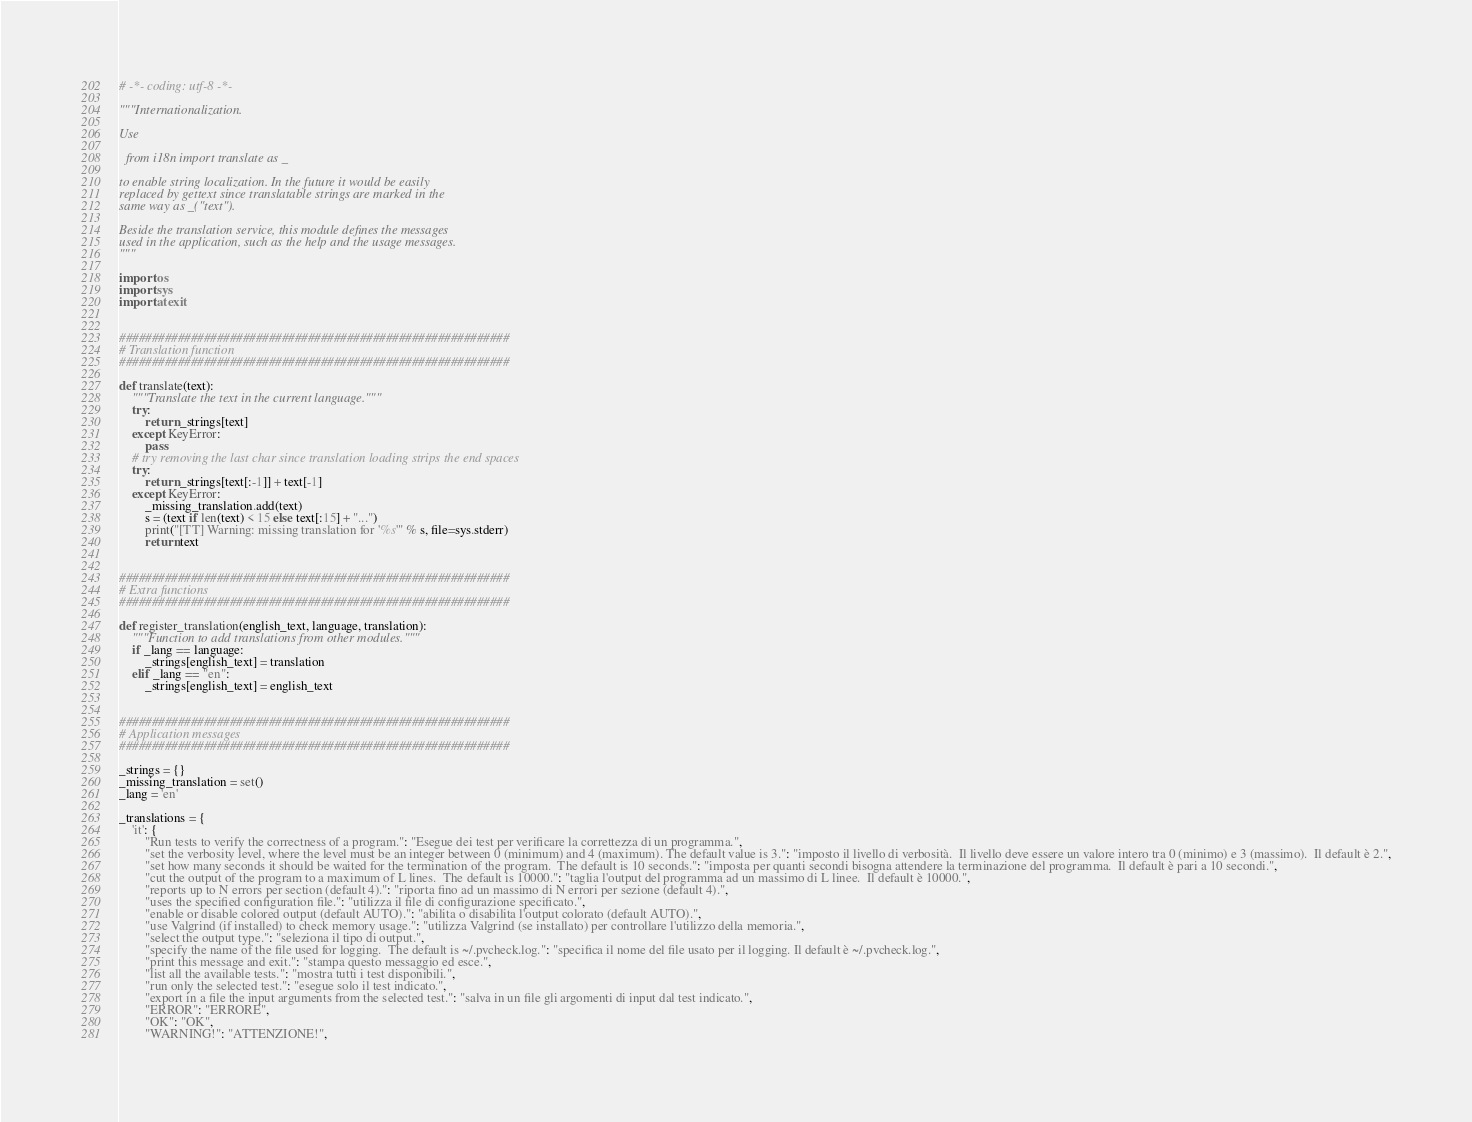<code> <loc_0><loc_0><loc_500><loc_500><_Python_># -*- coding: utf-8 -*-

"""Internationalization.

Use

  from i18n import translate as _

to enable string localization. In the future it would be easily
replaced by gettext since translatable strings are marked in the
same way as _("text").

Beside the translation service, this module defines the messages
used in the application, such as the help and the usage messages.
"""

import os
import sys
import atexit


############################################################
# Translation function
############################################################

def translate(text):
    """Translate the text in the current language."""
    try:
        return _strings[text]
    except KeyError:
        pass
    # try removing the last char since translation loading strips the end spaces
    try:
        return _strings[text[:-1]] + text[-1]
    except KeyError:
        _missing_translation.add(text)
        s = (text if len(text) < 15 else text[:15] + "...")
        print("[TT] Warning: missing translation for '%s'" % s, file=sys.stderr)
        return text


############################################################
# Extra functions
############################################################

def register_translation(english_text, language, translation):
    """Function to add translations from other modules."""
    if _lang == language:
        _strings[english_text] = translation
    elif _lang == "en":
        _strings[english_text] = english_text


############################################################
# Application messages
############################################################

_strings = {}
_missing_translation = set()
_lang = 'en'

_translations = {
    'it': {
        "Run tests to verify the correctness of a program.": "Esegue dei test per verificare la correttezza di un programma.",
        "set the verbosity level, where the level must be an integer between 0 (minimum) and 4 (maximum). The default value is 3.": "imposto il livello di verbosità.  Il livello deve essere un valore intero tra 0 (minimo) e 3 (massimo).  Il default è 2.",
        "set how many seconds it should be waited for the termination of the program.  The default is 10 seconds.": "imposta per quanti secondi bisogna attendere la terminazione del programma.  Il default è pari a 10 secondi.",
        "cut the output of the program to a maximum of L lines.  The default is 10000.": "taglia l'output del programma ad un massimo di L linee.  Il default è 10000.",
        "reports up to N errors per section (default 4).": "riporta fino ad un massimo di N errori per sezione (default 4).",
        "uses the specified configuration file.": "utilizza il file di configurazione specificato.",
        "enable or disable colored output (default AUTO).": "abilita o disabilita l'output colorato (default AUTO).",
        "use Valgrind (if installed) to check memory usage.": "utilizza Valgrind (se installato) per controllare l'utilizzo della memoria.",
        "select the output type.": "seleziona il tipo di output.",
        "specify the name of the file used for logging.  The default is ~/.pvcheck.log.": "specifica il nome del file usato per il logging. Il default è ~/.pvcheck.log.",
        "print this message and exit.": "stampa questo messaggio ed esce.",
        "list all the available tests.": "mostra tutti i test disponibili.",
        "run only the selected test.": "esegue solo il test indicato.",
        "export in a file the input arguments from the selected test.": "salva in un file gli argomenti di input dal test indicato.",
        "ERROR": "ERRORE",
        "OK": "OK",
        "WARNING!": "ATTENZIONE!",</code> 